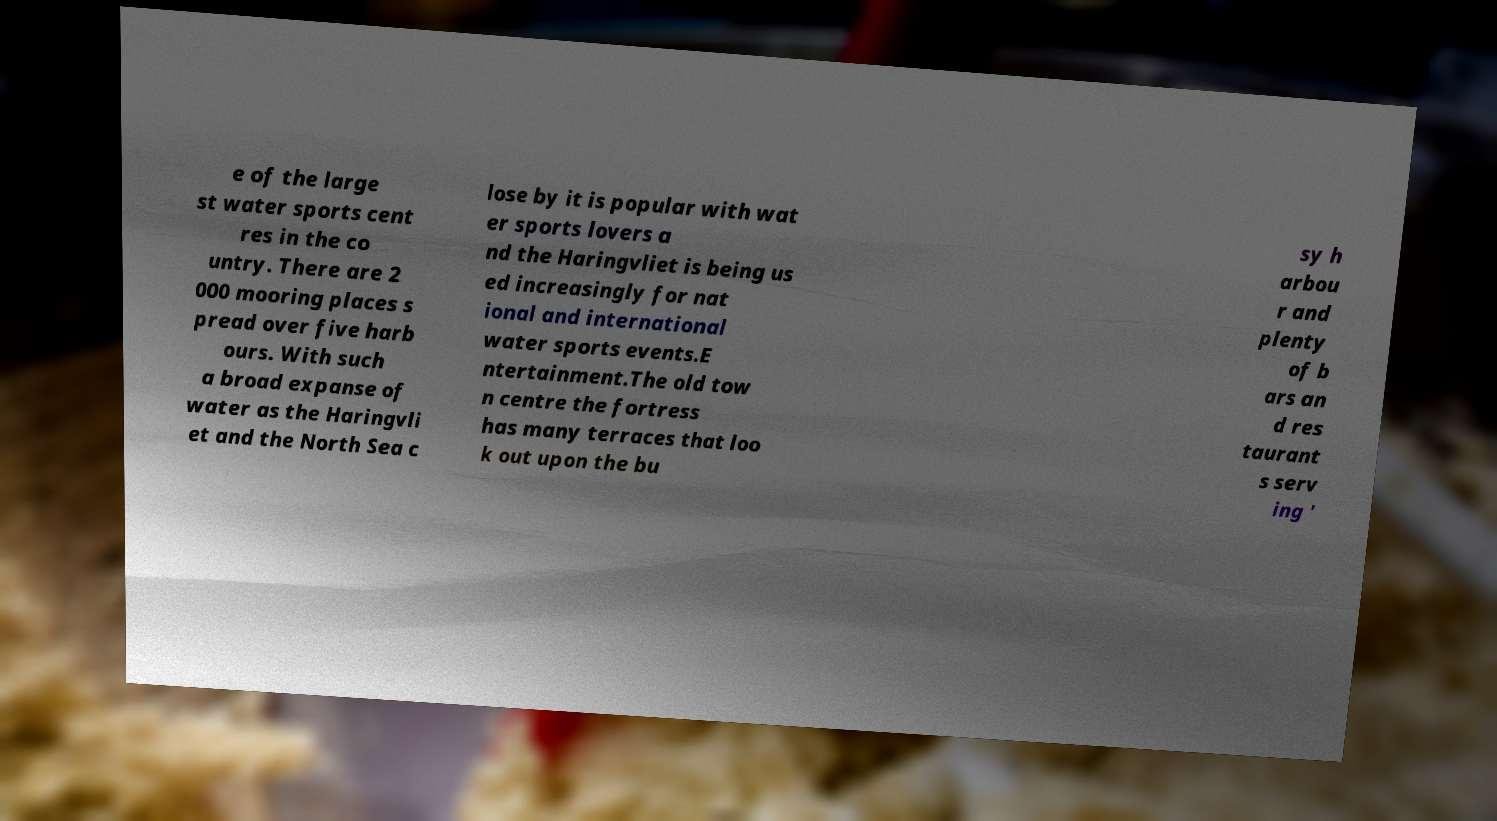Please read and relay the text visible in this image. What does it say? e of the large st water sports cent res in the co untry. There are 2 000 mooring places s pread over five harb ours. With such a broad expanse of water as the Haringvli et and the North Sea c lose by it is popular with wat er sports lovers a nd the Haringvliet is being us ed increasingly for nat ional and international water sports events.E ntertainment.The old tow n centre the fortress has many terraces that loo k out upon the bu sy h arbou r and plenty of b ars an d res taurant s serv ing ' 